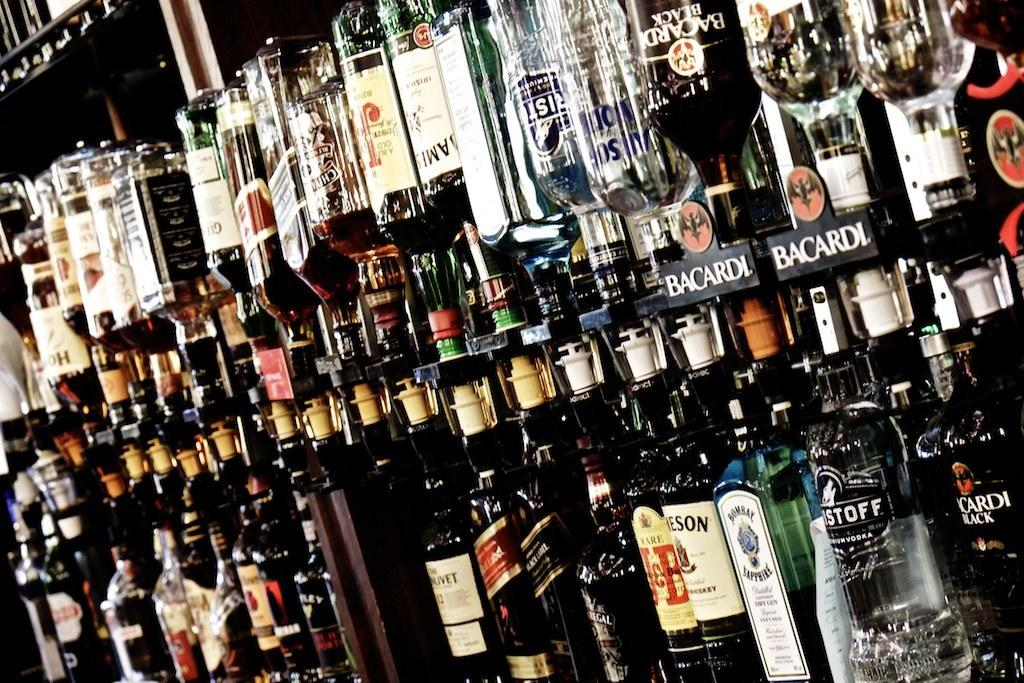What is contained in the bottles that are visible in the image? The bottles in the image are filled with liquid. What type of material are the pieces in the middle of the image made of? The pieces in the middle of the image are made of wood. What type of cream is used in the religious ceremony depicted in the image? There is no religious ceremony or cream present in the image; it only features bottles filled with liquid and wooden pieces. 